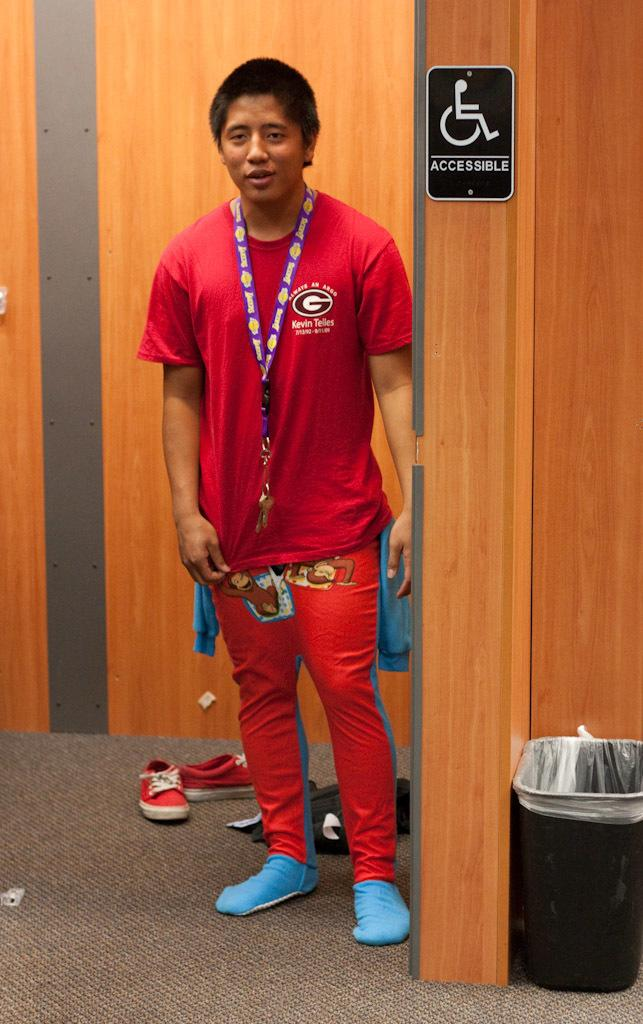<image>
Provide a brief description of the given image. A man, wearing a red shirt adorned with the letter G, stands next to a sign that says accessible with a picture of a disabled person. 